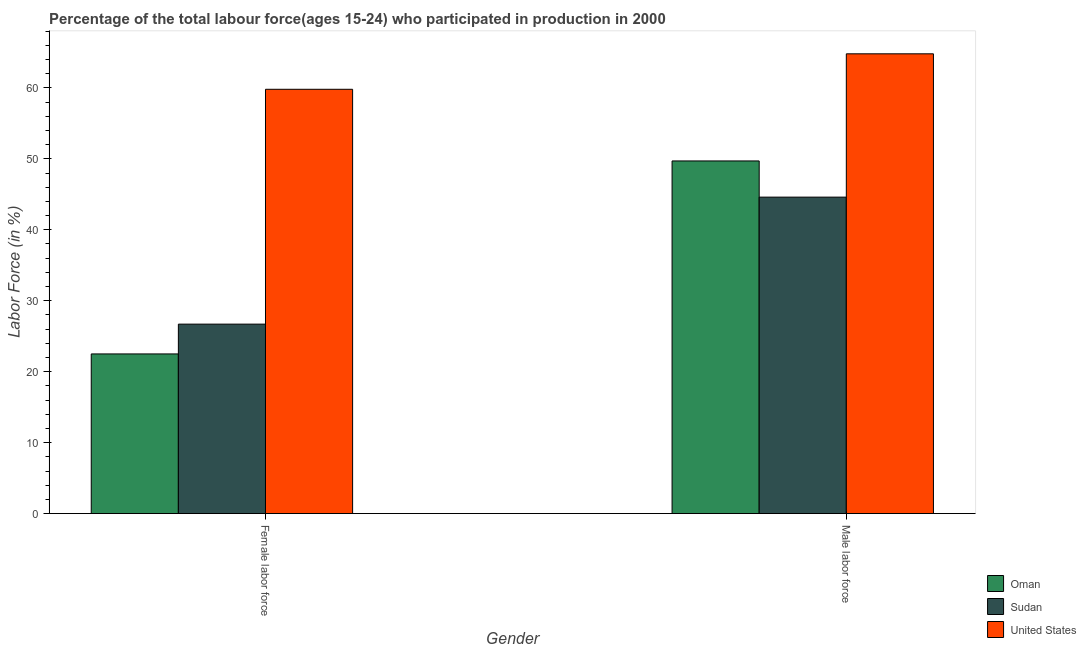How many different coloured bars are there?
Ensure brevity in your answer.  3. How many groups of bars are there?
Offer a terse response. 2. Are the number of bars on each tick of the X-axis equal?
Make the answer very short. Yes. How many bars are there on the 1st tick from the left?
Keep it short and to the point. 3. What is the label of the 2nd group of bars from the left?
Your answer should be very brief. Male labor force. What is the percentage of male labour force in Oman?
Your answer should be very brief. 49.7. Across all countries, what is the maximum percentage of male labour force?
Provide a succinct answer. 64.8. Across all countries, what is the minimum percentage of male labour force?
Provide a short and direct response. 44.6. In which country was the percentage of female labor force minimum?
Offer a terse response. Oman. What is the total percentage of male labour force in the graph?
Make the answer very short. 159.1. What is the difference between the percentage of male labour force in Oman and that in Sudan?
Your answer should be very brief. 5.1. What is the difference between the percentage of male labour force in Oman and the percentage of female labor force in Sudan?
Make the answer very short. 23. What is the average percentage of female labor force per country?
Ensure brevity in your answer.  36.33. What is the difference between the percentage of female labor force and percentage of male labour force in United States?
Your answer should be compact. -5. In how many countries, is the percentage of female labor force greater than 22 %?
Give a very brief answer. 3. What is the ratio of the percentage of female labor force in Oman to that in Sudan?
Provide a succinct answer. 0.84. Is the percentage of male labour force in Sudan less than that in United States?
Ensure brevity in your answer.  Yes. What does the 3rd bar from the left in Female labor force represents?
Make the answer very short. United States. What does the 3rd bar from the right in Male labor force represents?
Provide a succinct answer. Oman. How many countries are there in the graph?
Your response must be concise. 3. What is the difference between two consecutive major ticks on the Y-axis?
Make the answer very short. 10. Are the values on the major ticks of Y-axis written in scientific E-notation?
Ensure brevity in your answer.  No. Does the graph contain any zero values?
Give a very brief answer. No. Does the graph contain grids?
Offer a terse response. No. How many legend labels are there?
Your answer should be very brief. 3. How are the legend labels stacked?
Your response must be concise. Vertical. What is the title of the graph?
Ensure brevity in your answer.  Percentage of the total labour force(ages 15-24) who participated in production in 2000. Does "Guinea" appear as one of the legend labels in the graph?
Provide a succinct answer. No. What is the label or title of the Y-axis?
Provide a succinct answer. Labor Force (in %). What is the Labor Force (in %) of Oman in Female labor force?
Provide a short and direct response. 22.5. What is the Labor Force (in %) in Sudan in Female labor force?
Give a very brief answer. 26.7. What is the Labor Force (in %) of United States in Female labor force?
Offer a terse response. 59.8. What is the Labor Force (in %) in Oman in Male labor force?
Ensure brevity in your answer.  49.7. What is the Labor Force (in %) of Sudan in Male labor force?
Keep it short and to the point. 44.6. What is the Labor Force (in %) of United States in Male labor force?
Offer a terse response. 64.8. Across all Gender, what is the maximum Labor Force (in %) of Oman?
Your answer should be compact. 49.7. Across all Gender, what is the maximum Labor Force (in %) in Sudan?
Ensure brevity in your answer.  44.6. Across all Gender, what is the maximum Labor Force (in %) in United States?
Provide a short and direct response. 64.8. Across all Gender, what is the minimum Labor Force (in %) of Sudan?
Ensure brevity in your answer.  26.7. Across all Gender, what is the minimum Labor Force (in %) in United States?
Make the answer very short. 59.8. What is the total Labor Force (in %) in Oman in the graph?
Your answer should be compact. 72.2. What is the total Labor Force (in %) in Sudan in the graph?
Keep it short and to the point. 71.3. What is the total Labor Force (in %) in United States in the graph?
Offer a very short reply. 124.6. What is the difference between the Labor Force (in %) in Oman in Female labor force and that in Male labor force?
Make the answer very short. -27.2. What is the difference between the Labor Force (in %) of Sudan in Female labor force and that in Male labor force?
Your answer should be very brief. -17.9. What is the difference between the Labor Force (in %) in Oman in Female labor force and the Labor Force (in %) in Sudan in Male labor force?
Provide a short and direct response. -22.1. What is the difference between the Labor Force (in %) in Oman in Female labor force and the Labor Force (in %) in United States in Male labor force?
Give a very brief answer. -42.3. What is the difference between the Labor Force (in %) of Sudan in Female labor force and the Labor Force (in %) of United States in Male labor force?
Ensure brevity in your answer.  -38.1. What is the average Labor Force (in %) of Oman per Gender?
Give a very brief answer. 36.1. What is the average Labor Force (in %) in Sudan per Gender?
Provide a short and direct response. 35.65. What is the average Labor Force (in %) in United States per Gender?
Give a very brief answer. 62.3. What is the difference between the Labor Force (in %) in Oman and Labor Force (in %) in Sudan in Female labor force?
Keep it short and to the point. -4.2. What is the difference between the Labor Force (in %) in Oman and Labor Force (in %) in United States in Female labor force?
Provide a short and direct response. -37.3. What is the difference between the Labor Force (in %) of Sudan and Labor Force (in %) of United States in Female labor force?
Offer a terse response. -33.1. What is the difference between the Labor Force (in %) of Oman and Labor Force (in %) of Sudan in Male labor force?
Your answer should be compact. 5.1. What is the difference between the Labor Force (in %) in Oman and Labor Force (in %) in United States in Male labor force?
Provide a short and direct response. -15.1. What is the difference between the Labor Force (in %) of Sudan and Labor Force (in %) of United States in Male labor force?
Your answer should be very brief. -20.2. What is the ratio of the Labor Force (in %) of Oman in Female labor force to that in Male labor force?
Ensure brevity in your answer.  0.45. What is the ratio of the Labor Force (in %) in Sudan in Female labor force to that in Male labor force?
Provide a short and direct response. 0.6. What is the ratio of the Labor Force (in %) in United States in Female labor force to that in Male labor force?
Offer a very short reply. 0.92. What is the difference between the highest and the second highest Labor Force (in %) in Oman?
Provide a succinct answer. 27.2. What is the difference between the highest and the second highest Labor Force (in %) in Sudan?
Keep it short and to the point. 17.9. What is the difference between the highest and the second highest Labor Force (in %) of United States?
Offer a very short reply. 5. What is the difference between the highest and the lowest Labor Force (in %) of Oman?
Make the answer very short. 27.2. 